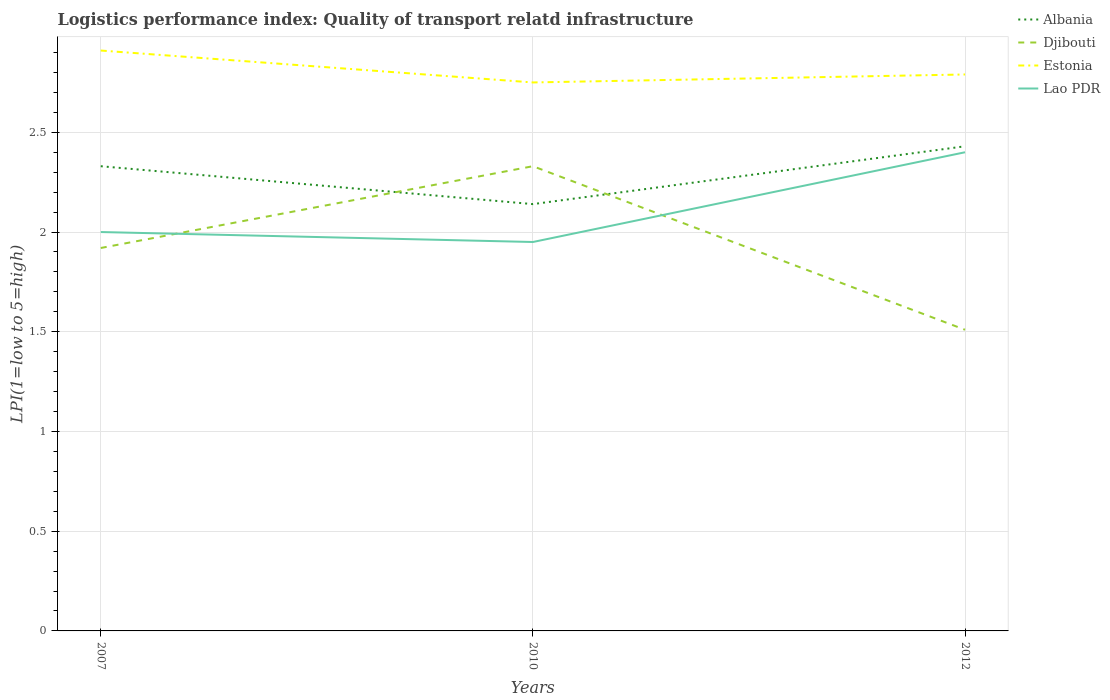Is the number of lines equal to the number of legend labels?
Your answer should be compact. Yes. Across all years, what is the maximum logistics performance index in Albania?
Provide a succinct answer. 2.14. What is the total logistics performance index in Lao PDR in the graph?
Your answer should be very brief. 0.05. What is the difference between the highest and the second highest logistics performance index in Djibouti?
Offer a terse response. 0.82. What is the difference between the highest and the lowest logistics performance index in Albania?
Your answer should be very brief. 2. Is the logistics performance index in Estonia strictly greater than the logistics performance index in Lao PDR over the years?
Offer a terse response. No. How many years are there in the graph?
Your answer should be compact. 3. What is the difference between two consecutive major ticks on the Y-axis?
Provide a short and direct response. 0.5. Does the graph contain any zero values?
Provide a succinct answer. No. Does the graph contain grids?
Offer a terse response. Yes. How many legend labels are there?
Provide a short and direct response. 4. How are the legend labels stacked?
Your response must be concise. Vertical. What is the title of the graph?
Offer a very short reply. Logistics performance index: Quality of transport relatd infrastructure. Does "Zambia" appear as one of the legend labels in the graph?
Keep it short and to the point. No. What is the label or title of the X-axis?
Make the answer very short. Years. What is the label or title of the Y-axis?
Keep it short and to the point. LPI(1=low to 5=high). What is the LPI(1=low to 5=high) of Albania in 2007?
Provide a succinct answer. 2.33. What is the LPI(1=low to 5=high) in Djibouti in 2007?
Offer a terse response. 1.92. What is the LPI(1=low to 5=high) in Estonia in 2007?
Your answer should be compact. 2.91. What is the LPI(1=low to 5=high) in Lao PDR in 2007?
Your answer should be compact. 2. What is the LPI(1=low to 5=high) in Albania in 2010?
Provide a short and direct response. 2.14. What is the LPI(1=low to 5=high) of Djibouti in 2010?
Your response must be concise. 2.33. What is the LPI(1=low to 5=high) in Estonia in 2010?
Give a very brief answer. 2.75. What is the LPI(1=low to 5=high) in Lao PDR in 2010?
Provide a succinct answer. 1.95. What is the LPI(1=low to 5=high) of Albania in 2012?
Your answer should be very brief. 2.43. What is the LPI(1=low to 5=high) of Djibouti in 2012?
Ensure brevity in your answer.  1.51. What is the LPI(1=low to 5=high) in Estonia in 2012?
Provide a succinct answer. 2.79. What is the LPI(1=low to 5=high) in Lao PDR in 2012?
Offer a terse response. 2.4. Across all years, what is the maximum LPI(1=low to 5=high) of Albania?
Ensure brevity in your answer.  2.43. Across all years, what is the maximum LPI(1=low to 5=high) in Djibouti?
Provide a succinct answer. 2.33. Across all years, what is the maximum LPI(1=low to 5=high) in Estonia?
Give a very brief answer. 2.91. Across all years, what is the maximum LPI(1=low to 5=high) in Lao PDR?
Offer a terse response. 2.4. Across all years, what is the minimum LPI(1=low to 5=high) in Albania?
Keep it short and to the point. 2.14. Across all years, what is the minimum LPI(1=low to 5=high) in Djibouti?
Your answer should be very brief. 1.51. Across all years, what is the minimum LPI(1=low to 5=high) in Estonia?
Give a very brief answer. 2.75. Across all years, what is the minimum LPI(1=low to 5=high) of Lao PDR?
Make the answer very short. 1.95. What is the total LPI(1=low to 5=high) of Albania in the graph?
Provide a short and direct response. 6.9. What is the total LPI(1=low to 5=high) of Djibouti in the graph?
Provide a short and direct response. 5.76. What is the total LPI(1=low to 5=high) of Estonia in the graph?
Give a very brief answer. 8.45. What is the total LPI(1=low to 5=high) of Lao PDR in the graph?
Your answer should be compact. 6.35. What is the difference between the LPI(1=low to 5=high) of Albania in 2007 and that in 2010?
Ensure brevity in your answer.  0.19. What is the difference between the LPI(1=low to 5=high) of Djibouti in 2007 and that in 2010?
Keep it short and to the point. -0.41. What is the difference between the LPI(1=low to 5=high) of Estonia in 2007 and that in 2010?
Provide a short and direct response. 0.16. What is the difference between the LPI(1=low to 5=high) of Albania in 2007 and that in 2012?
Offer a very short reply. -0.1. What is the difference between the LPI(1=low to 5=high) of Djibouti in 2007 and that in 2012?
Give a very brief answer. 0.41. What is the difference between the LPI(1=low to 5=high) in Estonia in 2007 and that in 2012?
Your response must be concise. 0.12. What is the difference between the LPI(1=low to 5=high) in Lao PDR in 2007 and that in 2012?
Provide a succinct answer. -0.4. What is the difference between the LPI(1=low to 5=high) of Albania in 2010 and that in 2012?
Make the answer very short. -0.29. What is the difference between the LPI(1=low to 5=high) in Djibouti in 2010 and that in 2012?
Ensure brevity in your answer.  0.82. What is the difference between the LPI(1=low to 5=high) of Estonia in 2010 and that in 2012?
Keep it short and to the point. -0.04. What is the difference between the LPI(1=low to 5=high) of Lao PDR in 2010 and that in 2012?
Ensure brevity in your answer.  -0.45. What is the difference between the LPI(1=low to 5=high) of Albania in 2007 and the LPI(1=low to 5=high) of Estonia in 2010?
Your answer should be very brief. -0.42. What is the difference between the LPI(1=low to 5=high) of Albania in 2007 and the LPI(1=low to 5=high) of Lao PDR in 2010?
Give a very brief answer. 0.38. What is the difference between the LPI(1=low to 5=high) in Djibouti in 2007 and the LPI(1=low to 5=high) in Estonia in 2010?
Offer a terse response. -0.83. What is the difference between the LPI(1=low to 5=high) of Djibouti in 2007 and the LPI(1=low to 5=high) of Lao PDR in 2010?
Offer a terse response. -0.03. What is the difference between the LPI(1=low to 5=high) of Estonia in 2007 and the LPI(1=low to 5=high) of Lao PDR in 2010?
Your answer should be very brief. 0.96. What is the difference between the LPI(1=low to 5=high) in Albania in 2007 and the LPI(1=low to 5=high) in Djibouti in 2012?
Keep it short and to the point. 0.82. What is the difference between the LPI(1=low to 5=high) in Albania in 2007 and the LPI(1=low to 5=high) in Estonia in 2012?
Your answer should be very brief. -0.46. What is the difference between the LPI(1=low to 5=high) in Albania in 2007 and the LPI(1=low to 5=high) in Lao PDR in 2012?
Provide a short and direct response. -0.07. What is the difference between the LPI(1=low to 5=high) in Djibouti in 2007 and the LPI(1=low to 5=high) in Estonia in 2012?
Offer a terse response. -0.87. What is the difference between the LPI(1=low to 5=high) of Djibouti in 2007 and the LPI(1=low to 5=high) of Lao PDR in 2012?
Your answer should be compact. -0.48. What is the difference between the LPI(1=low to 5=high) in Estonia in 2007 and the LPI(1=low to 5=high) in Lao PDR in 2012?
Provide a short and direct response. 0.51. What is the difference between the LPI(1=low to 5=high) in Albania in 2010 and the LPI(1=low to 5=high) in Djibouti in 2012?
Ensure brevity in your answer.  0.63. What is the difference between the LPI(1=low to 5=high) in Albania in 2010 and the LPI(1=low to 5=high) in Estonia in 2012?
Your answer should be compact. -0.65. What is the difference between the LPI(1=low to 5=high) in Albania in 2010 and the LPI(1=low to 5=high) in Lao PDR in 2012?
Your answer should be very brief. -0.26. What is the difference between the LPI(1=low to 5=high) of Djibouti in 2010 and the LPI(1=low to 5=high) of Estonia in 2012?
Provide a short and direct response. -0.46. What is the difference between the LPI(1=low to 5=high) in Djibouti in 2010 and the LPI(1=low to 5=high) in Lao PDR in 2012?
Keep it short and to the point. -0.07. What is the difference between the LPI(1=low to 5=high) of Estonia in 2010 and the LPI(1=low to 5=high) of Lao PDR in 2012?
Your answer should be very brief. 0.35. What is the average LPI(1=low to 5=high) of Djibouti per year?
Ensure brevity in your answer.  1.92. What is the average LPI(1=low to 5=high) of Estonia per year?
Offer a very short reply. 2.82. What is the average LPI(1=low to 5=high) of Lao PDR per year?
Your response must be concise. 2.12. In the year 2007, what is the difference between the LPI(1=low to 5=high) of Albania and LPI(1=low to 5=high) of Djibouti?
Provide a succinct answer. 0.41. In the year 2007, what is the difference between the LPI(1=low to 5=high) of Albania and LPI(1=low to 5=high) of Estonia?
Your answer should be very brief. -0.58. In the year 2007, what is the difference between the LPI(1=low to 5=high) in Albania and LPI(1=low to 5=high) in Lao PDR?
Give a very brief answer. 0.33. In the year 2007, what is the difference between the LPI(1=low to 5=high) in Djibouti and LPI(1=low to 5=high) in Estonia?
Your answer should be very brief. -0.99. In the year 2007, what is the difference between the LPI(1=low to 5=high) in Djibouti and LPI(1=low to 5=high) in Lao PDR?
Give a very brief answer. -0.08. In the year 2007, what is the difference between the LPI(1=low to 5=high) in Estonia and LPI(1=low to 5=high) in Lao PDR?
Make the answer very short. 0.91. In the year 2010, what is the difference between the LPI(1=low to 5=high) in Albania and LPI(1=low to 5=high) in Djibouti?
Ensure brevity in your answer.  -0.19. In the year 2010, what is the difference between the LPI(1=low to 5=high) in Albania and LPI(1=low to 5=high) in Estonia?
Offer a very short reply. -0.61. In the year 2010, what is the difference between the LPI(1=low to 5=high) in Albania and LPI(1=low to 5=high) in Lao PDR?
Give a very brief answer. 0.19. In the year 2010, what is the difference between the LPI(1=low to 5=high) in Djibouti and LPI(1=low to 5=high) in Estonia?
Keep it short and to the point. -0.42. In the year 2010, what is the difference between the LPI(1=low to 5=high) of Djibouti and LPI(1=low to 5=high) of Lao PDR?
Offer a very short reply. 0.38. In the year 2012, what is the difference between the LPI(1=low to 5=high) in Albania and LPI(1=low to 5=high) in Estonia?
Ensure brevity in your answer.  -0.36. In the year 2012, what is the difference between the LPI(1=low to 5=high) of Djibouti and LPI(1=low to 5=high) of Estonia?
Give a very brief answer. -1.28. In the year 2012, what is the difference between the LPI(1=low to 5=high) of Djibouti and LPI(1=low to 5=high) of Lao PDR?
Provide a succinct answer. -0.89. In the year 2012, what is the difference between the LPI(1=low to 5=high) of Estonia and LPI(1=low to 5=high) of Lao PDR?
Your answer should be very brief. 0.39. What is the ratio of the LPI(1=low to 5=high) of Albania in 2007 to that in 2010?
Your answer should be very brief. 1.09. What is the ratio of the LPI(1=low to 5=high) in Djibouti in 2007 to that in 2010?
Ensure brevity in your answer.  0.82. What is the ratio of the LPI(1=low to 5=high) of Estonia in 2007 to that in 2010?
Make the answer very short. 1.06. What is the ratio of the LPI(1=low to 5=high) of Lao PDR in 2007 to that in 2010?
Your answer should be compact. 1.03. What is the ratio of the LPI(1=low to 5=high) in Albania in 2007 to that in 2012?
Provide a short and direct response. 0.96. What is the ratio of the LPI(1=low to 5=high) of Djibouti in 2007 to that in 2012?
Provide a short and direct response. 1.27. What is the ratio of the LPI(1=low to 5=high) of Estonia in 2007 to that in 2012?
Offer a very short reply. 1.04. What is the ratio of the LPI(1=low to 5=high) in Albania in 2010 to that in 2012?
Ensure brevity in your answer.  0.88. What is the ratio of the LPI(1=low to 5=high) in Djibouti in 2010 to that in 2012?
Make the answer very short. 1.54. What is the ratio of the LPI(1=low to 5=high) of Estonia in 2010 to that in 2012?
Ensure brevity in your answer.  0.99. What is the ratio of the LPI(1=low to 5=high) in Lao PDR in 2010 to that in 2012?
Provide a short and direct response. 0.81. What is the difference between the highest and the second highest LPI(1=low to 5=high) of Albania?
Keep it short and to the point. 0.1. What is the difference between the highest and the second highest LPI(1=low to 5=high) in Djibouti?
Offer a very short reply. 0.41. What is the difference between the highest and the second highest LPI(1=low to 5=high) of Estonia?
Offer a terse response. 0.12. What is the difference between the highest and the lowest LPI(1=low to 5=high) of Albania?
Your response must be concise. 0.29. What is the difference between the highest and the lowest LPI(1=low to 5=high) in Djibouti?
Provide a succinct answer. 0.82. What is the difference between the highest and the lowest LPI(1=low to 5=high) in Estonia?
Offer a very short reply. 0.16. What is the difference between the highest and the lowest LPI(1=low to 5=high) in Lao PDR?
Provide a short and direct response. 0.45. 